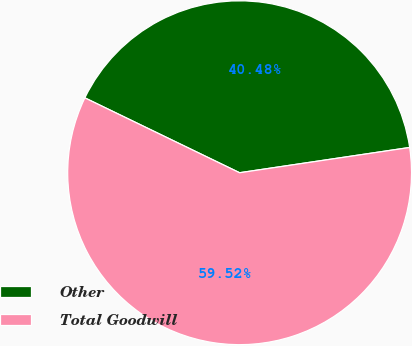Convert chart. <chart><loc_0><loc_0><loc_500><loc_500><pie_chart><fcel>Other<fcel>Total Goodwill<nl><fcel>40.48%<fcel>59.52%<nl></chart> 